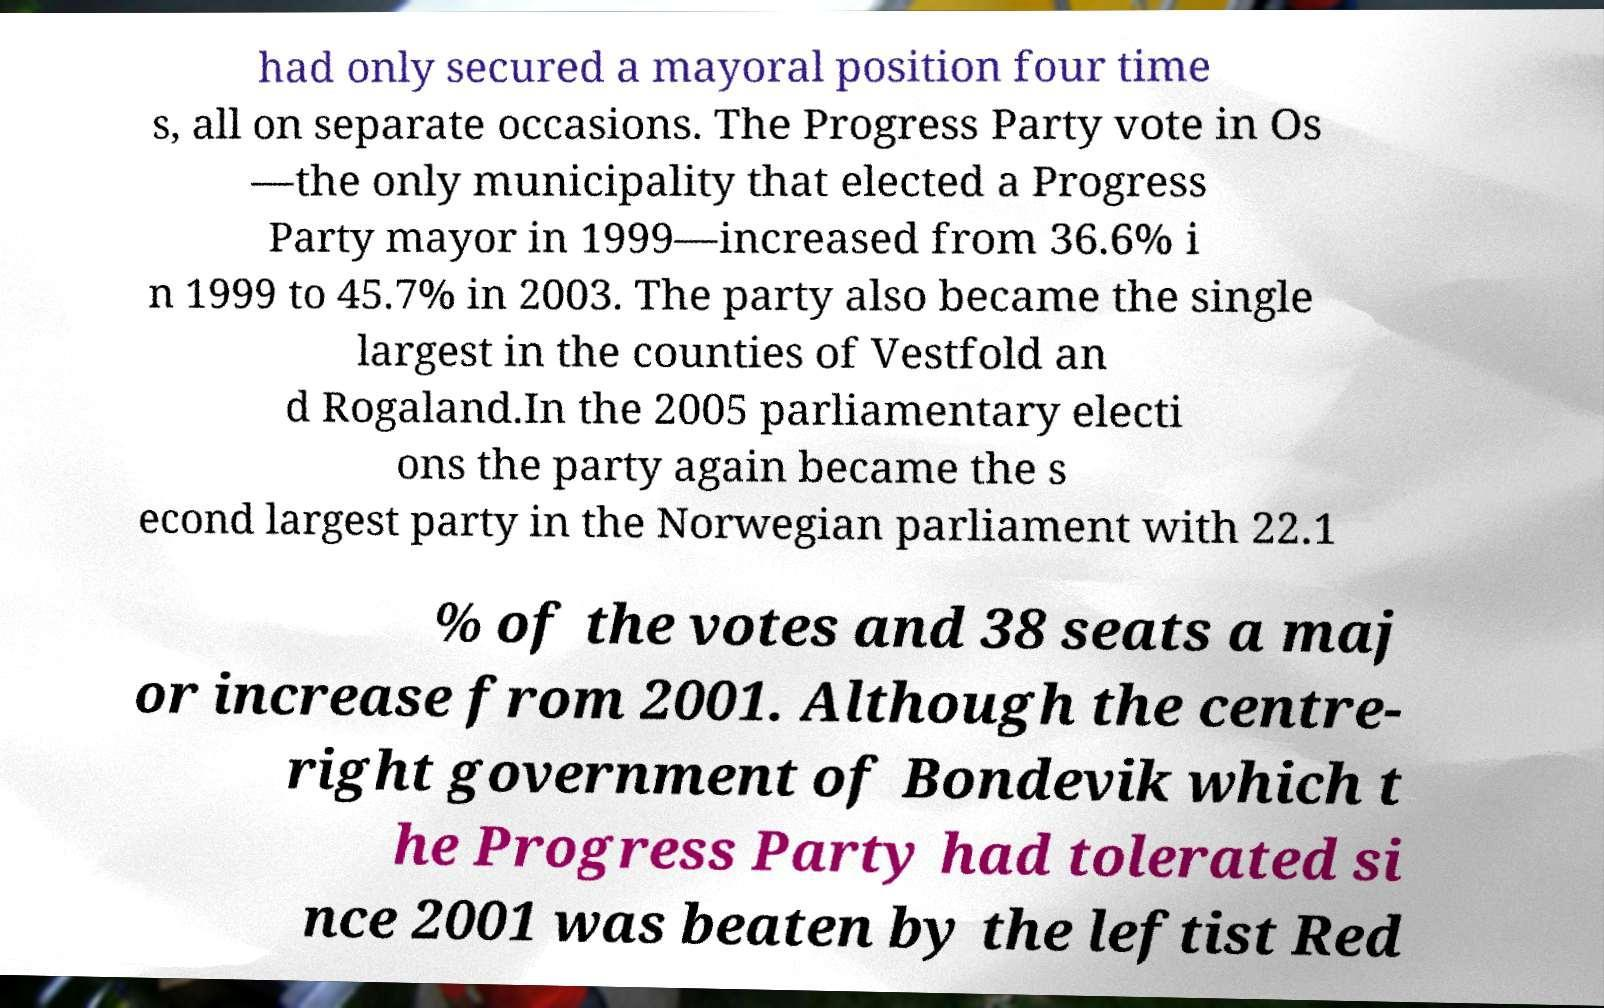Could you extract and type out the text from this image? had only secured a mayoral position four time s, all on separate occasions. The Progress Party vote in Os —the only municipality that elected a Progress Party mayor in 1999—increased from 36.6% i n 1999 to 45.7% in 2003. The party also became the single largest in the counties of Vestfold an d Rogaland.In the 2005 parliamentary electi ons the party again became the s econd largest party in the Norwegian parliament with 22.1 % of the votes and 38 seats a maj or increase from 2001. Although the centre- right government of Bondevik which t he Progress Party had tolerated si nce 2001 was beaten by the leftist Red 